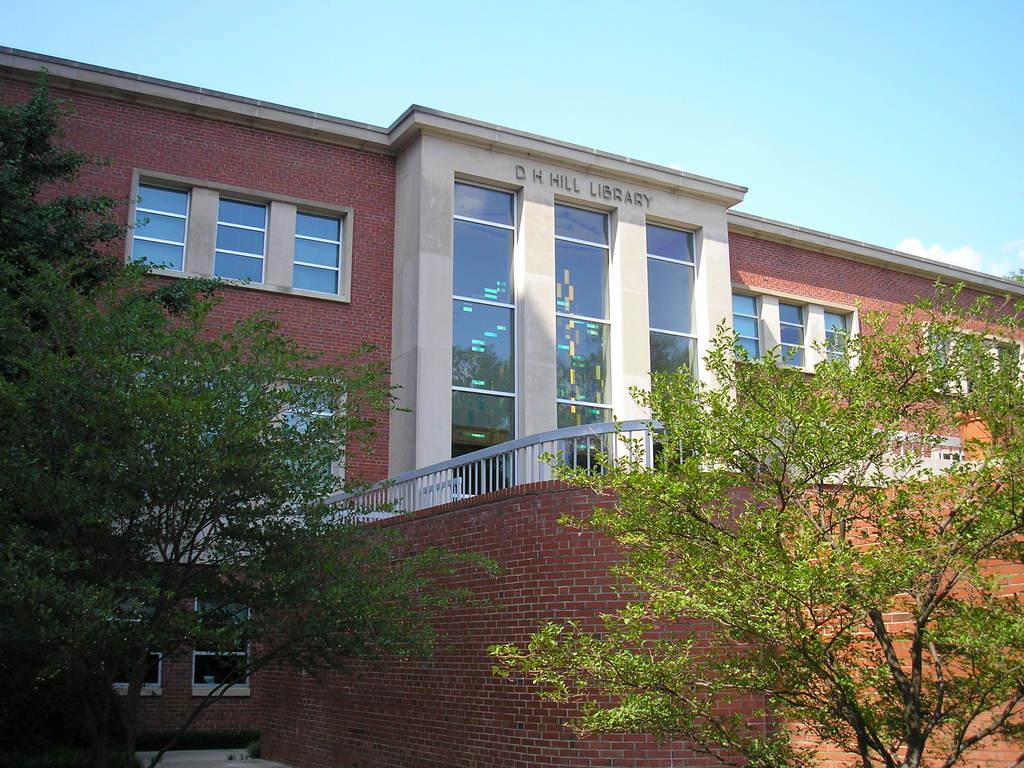What type of vegetation can be seen in the image? There are trees in the image. What architectural feature is present in the image? There is a wall in the image. What type of structure is visible in the image? There is a building with windows in the image. What is visible in the background of the image? The sky is visible behind the building. Where is the dock located in the image? There is no dock present in the image. What type of payment is accepted at the border in the image? There is no border or payment mentioned in the image. 